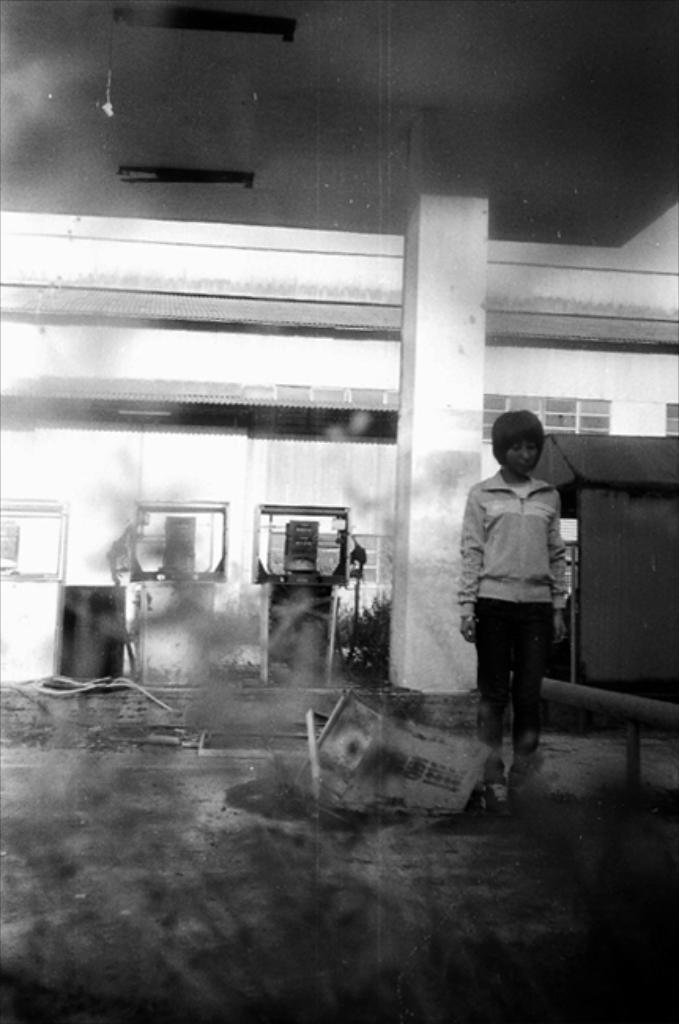In one or two sentences, can you explain what this image depicts? In this image we can see a person standing on the floor. Here we can see a machine on the floor. In the background, we can see the building. This is looking like a tent on the right side. 